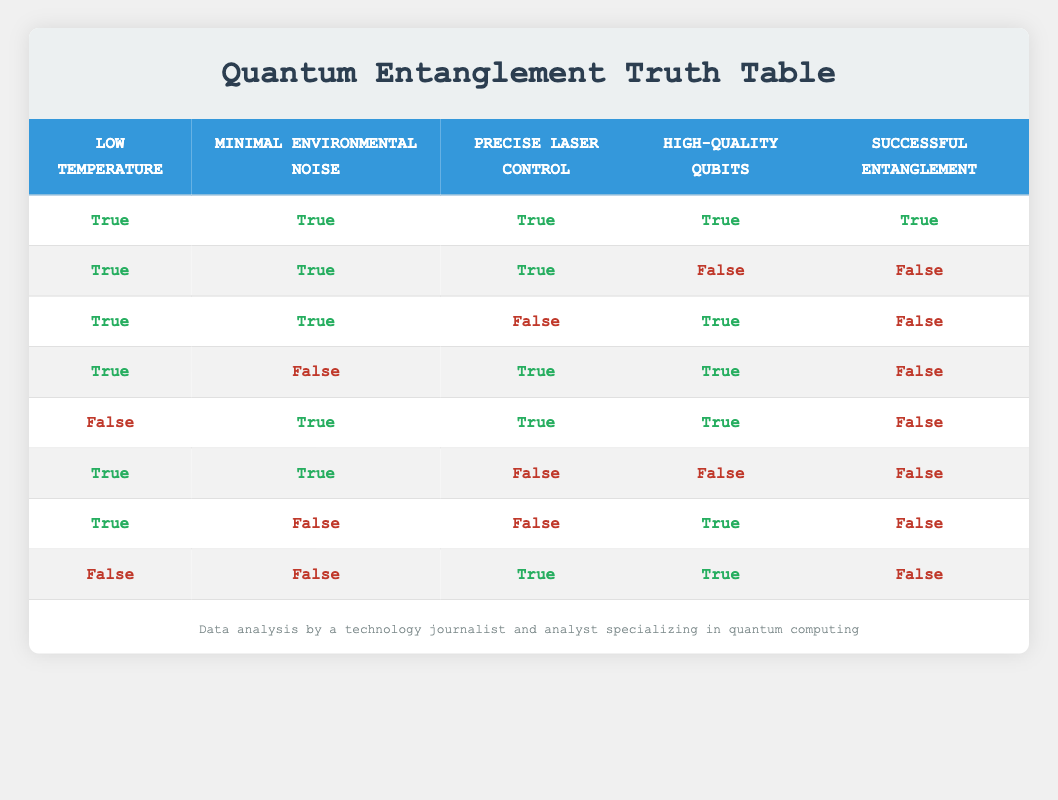What are the conditions that led to successful entanglement? From the table, successful entanglement occurred when all four conditions—Low Temperature, Minimal Environmental Noise, Precise Laser Control, and High-Quality Qubits—are true. This is clear in the first row of the table.
Answer: Low Temperature, Minimal Environmental Noise, Precise Laser Control, High-Quality Qubits How many conditions contributed to failed entanglement in the first row? The first row shows all four conditions are true, resulting in successful entanglement. Without any failed conditions in that row, we focus on the others for failed results. In the other seven rows, at least one condition is false.
Answer: Four Is precise laser control necessary for successful entanglement? The first row shows that successful entanglement is achieved only when Precise Laser Control is true. In other rows where it is false, entanglement fails, indicating its necessity.
Answer: Yes What combination of conditions resulted in failed entanglement despite having high-quality qubits? The second row shows that even with High-Quality Qubits, if Precise Laser Control is false while the other two conditions are true, entanglement fails.
Answer: Minimal Environmental Noise, Low Temperature, High-Quality Qubits (Precise Laser Control: false) What is the percentage of scenarios that resulted in successful entanglement? There are 8 total scenarios presented in the table, with only 1 scenario resulting in successful entanglement. The percentage is calculated as (1/8) * 100%, yielding 12.5%.
Answer: 12.5% 